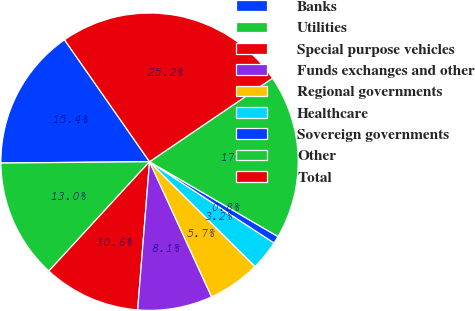Convert chart. <chart><loc_0><loc_0><loc_500><loc_500><pie_chart><fcel>Banks<fcel>Utilities<fcel>Special purpose vehicles<fcel>Funds exchanges and other<fcel>Regional governments<fcel>Healthcare<fcel>Sovereign governments<fcel>Other<fcel>Total<nl><fcel>15.45%<fcel>13.01%<fcel>10.57%<fcel>8.13%<fcel>5.69%<fcel>3.25%<fcel>0.81%<fcel>17.89%<fcel>25.2%<nl></chart> 